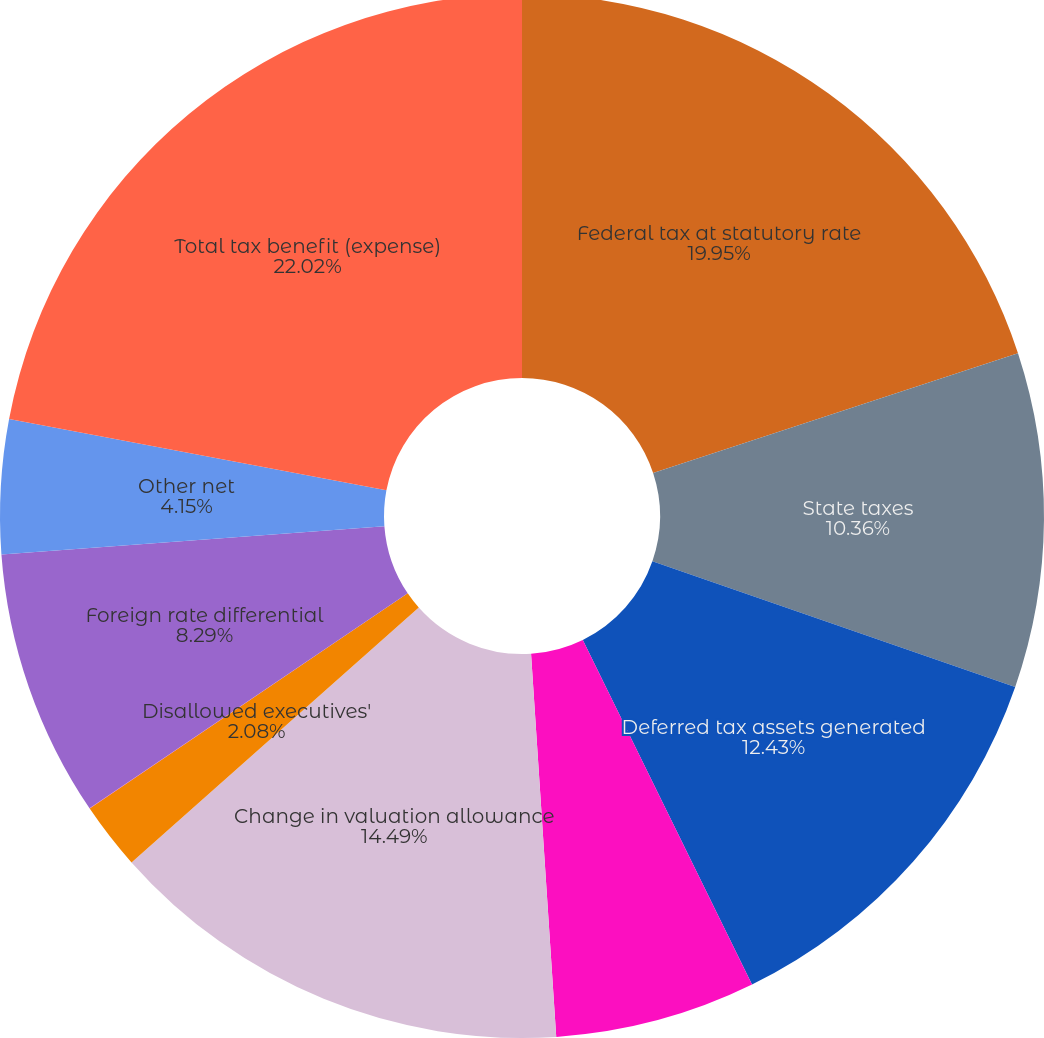Convert chart to OTSL. <chart><loc_0><loc_0><loc_500><loc_500><pie_chart><fcel>Federal tax at statutory rate<fcel>State taxes<fcel>Deferred tax assets generated<fcel>Stock option deduction<fcel>Change in valuation allowance<fcel>Disallowed executives'<fcel>Uncertain tax positions<fcel>Foreign rate differential<fcel>Other net<fcel>Total tax benefit (expense)<nl><fcel>19.96%<fcel>10.36%<fcel>12.43%<fcel>6.22%<fcel>14.5%<fcel>2.08%<fcel>0.01%<fcel>8.29%<fcel>4.15%<fcel>22.03%<nl></chart> 